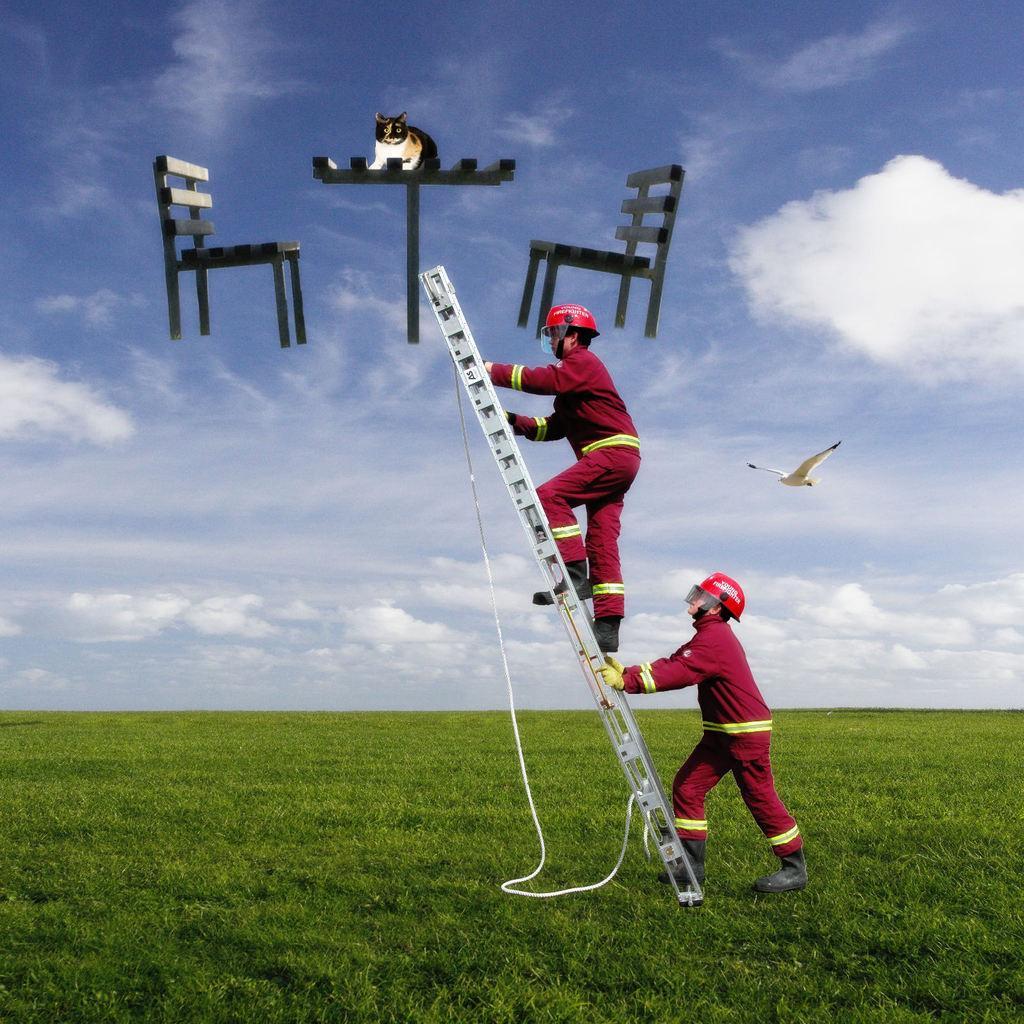Describe this image in one or two sentences. In this image I can see two people holding the ladder and there is a rope to it. I can see two chairs and table in the air. I can see the cat on the table. In the background I can see the clouds and the sky. I can see the bird in the air. 